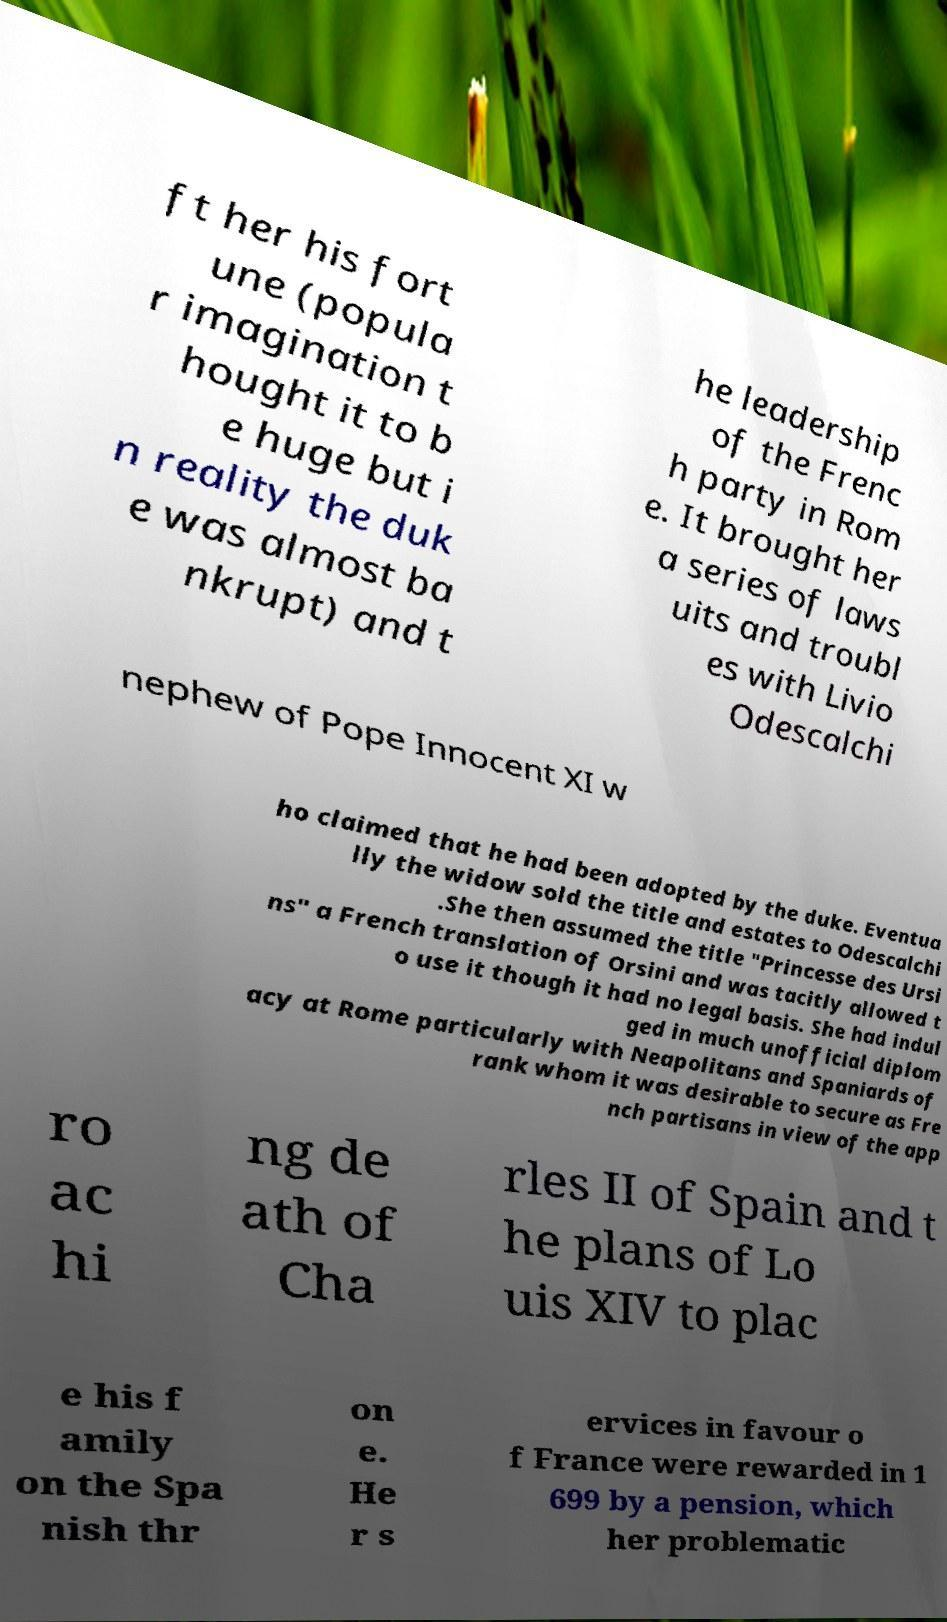Can you accurately transcribe the text from the provided image for me? ft her his fort une (popula r imagination t hought it to b e huge but i n reality the duk e was almost ba nkrupt) and t he leadership of the Frenc h party in Rom e. It brought her a series of laws uits and troubl es with Livio Odescalchi nephew of Pope Innocent XI w ho claimed that he had been adopted by the duke. Eventua lly the widow sold the title and estates to Odescalchi .She then assumed the title "Princesse des Ursi ns" a French translation of Orsini and was tacitly allowed t o use it though it had no legal basis. She had indul ged in much unofficial diplom acy at Rome particularly with Neapolitans and Spaniards of rank whom it was desirable to secure as Fre nch partisans in view of the app ro ac hi ng de ath of Cha rles II of Spain and t he plans of Lo uis XIV to plac e his f amily on the Spa nish thr on e. He r s ervices in favour o f France were rewarded in 1 699 by a pension, which her problematic 